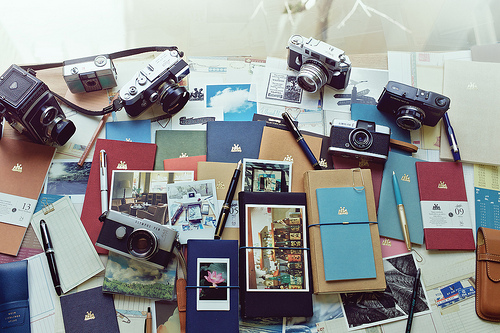<image>
Is there a camera in the photo? No. The camera is not contained within the photo. These objects have a different spatial relationship. 